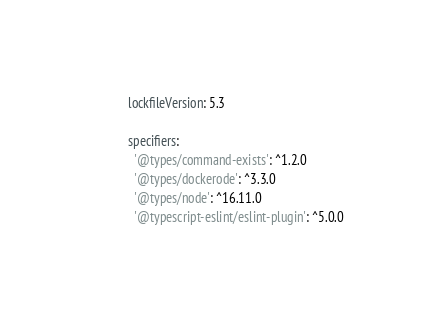Convert code to text. <code><loc_0><loc_0><loc_500><loc_500><_YAML_>lockfileVersion: 5.3

specifiers:
  '@types/command-exists': ^1.2.0
  '@types/dockerode': ^3.3.0
  '@types/node': ^16.11.0
  '@typescript-eslint/eslint-plugin': ^5.0.0</code> 